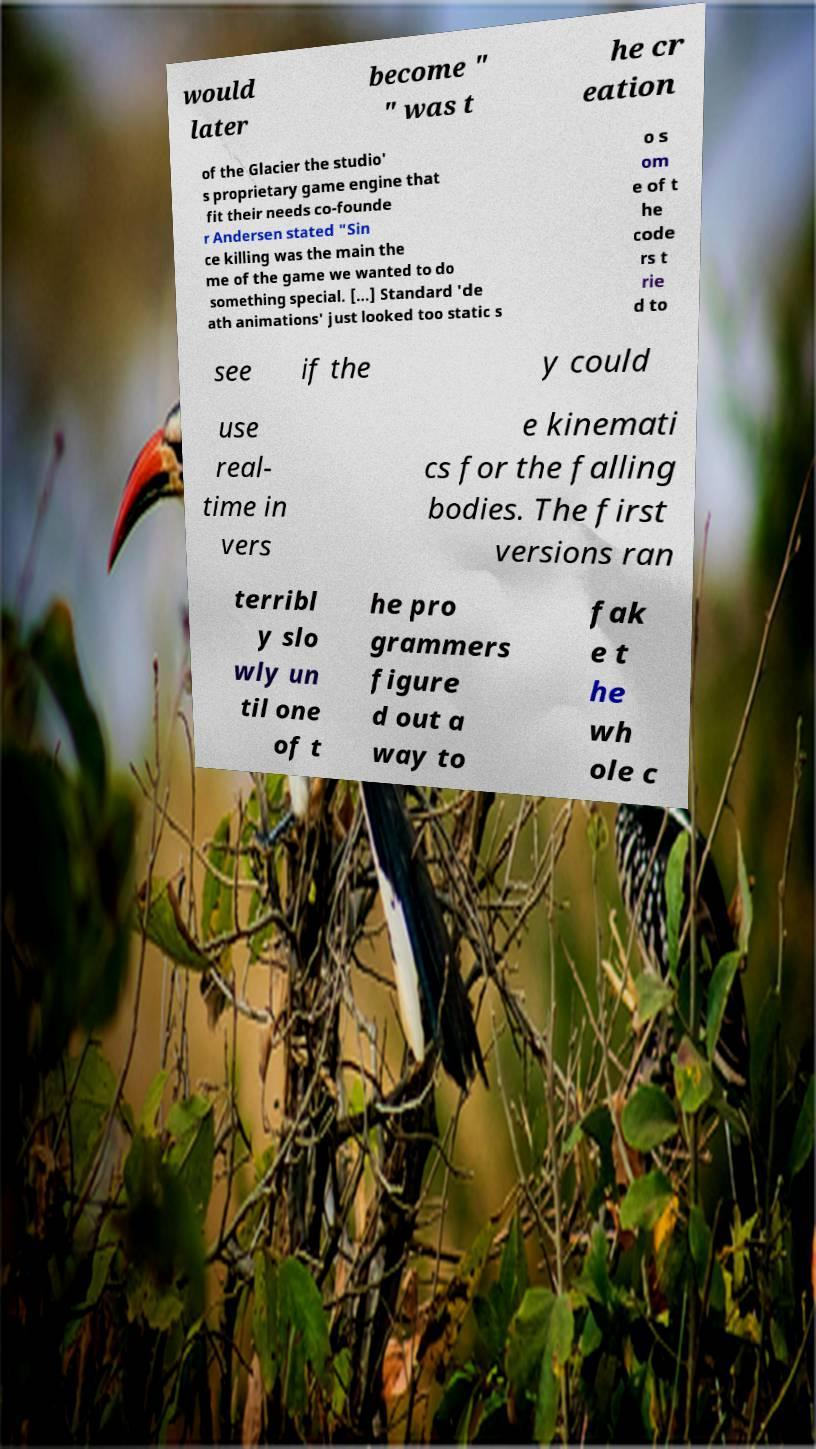What messages or text are displayed in this image? I need them in a readable, typed format. would later become " " was t he cr eation of the Glacier the studio' s proprietary game engine that fit their needs co-founde r Andersen stated "Sin ce killing was the main the me of the game we wanted to do something special. [...] Standard 'de ath animations' just looked too static s o s om e of t he code rs t rie d to see if the y could use real- time in vers e kinemati cs for the falling bodies. The first versions ran terribl y slo wly un til one of t he pro grammers figure d out a way to fak e t he wh ole c 